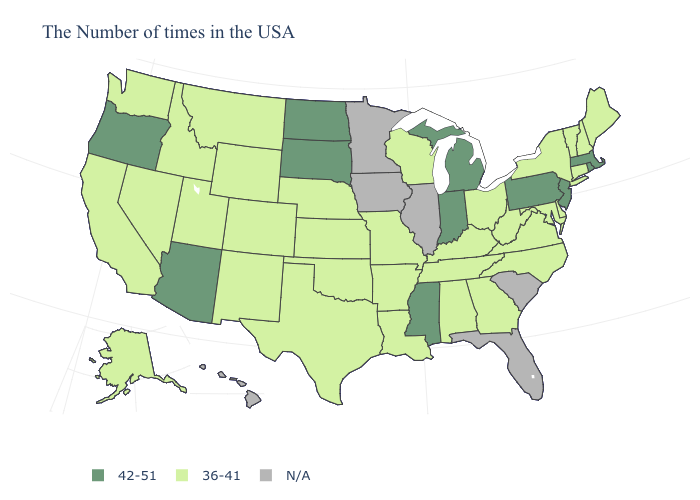Name the states that have a value in the range N/A?
Write a very short answer. South Carolina, Florida, Illinois, Minnesota, Iowa, Hawaii. What is the value of Maryland?
Be succinct. 36-41. Does New Jersey have the lowest value in the Northeast?
Answer briefly. No. Name the states that have a value in the range 36-41?
Keep it brief. Maine, New Hampshire, Vermont, Connecticut, New York, Delaware, Maryland, Virginia, North Carolina, West Virginia, Ohio, Georgia, Kentucky, Alabama, Tennessee, Wisconsin, Louisiana, Missouri, Arkansas, Kansas, Nebraska, Oklahoma, Texas, Wyoming, Colorado, New Mexico, Utah, Montana, Idaho, Nevada, California, Washington, Alaska. Is the legend a continuous bar?
Be succinct. No. What is the value of Arkansas?
Be succinct. 36-41. Which states hav the highest value in the West?
Concise answer only. Arizona, Oregon. Name the states that have a value in the range N/A?
Be succinct. South Carolina, Florida, Illinois, Minnesota, Iowa, Hawaii. How many symbols are there in the legend?
Short answer required. 3. Does Missouri have the highest value in the USA?
Write a very short answer. No. Does North Carolina have the highest value in the South?
Answer briefly. No. What is the value of Delaware?
Concise answer only. 36-41. What is the highest value in the USA?
Quick response, please. 42-51. 